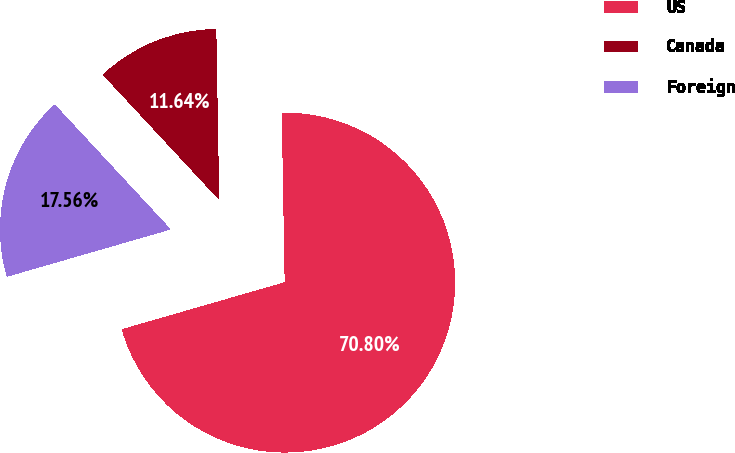Convert chart to OTSL. <chart><loc_0><loc_0><loc_500><loc_500><pie_chart><fcel>US<fcel>Canada<fcel>Foreign<nl><fcel>70.8%<fcel>11.64%<fcel>17.56%<nl></chart> 